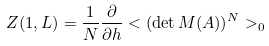Convert formula to latex. <formula><loc_0><loc_0><loc_500><loc_500>Z ( 1 , L ) = \frac { 1 } { N } \frac { \partial } { \partial h } < ( \det M ( A ) ) ^ { N } > _ { 0 }</formula> 